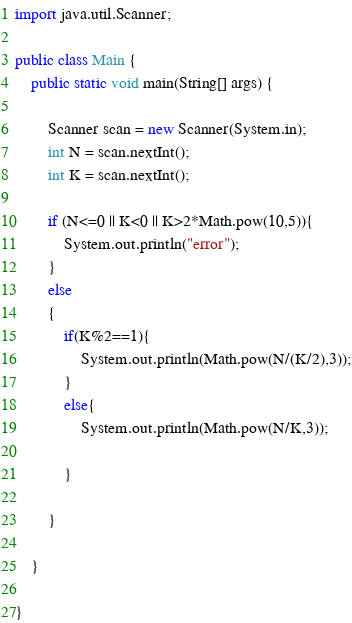Convert code to text. <code><loc_0><loc_0><loc_500><loc_500><_Java_>import java.util.Scanner;

public class Main {
	public static void main(String[] args) {
	
		Scanner scan = new Scanner(System.in);
		int N = scan.nextInt();
		int K = scan.nextInt();
		
		if (N<=0 || K<0 || K>2*Math.pow(10,5)){
			System.out.println("error");
		}
		else
		{
			if(K%2==1){
				System.out.println(Math.pow(N/(K/2),3));
			}
			else{
				System.out.println(Math.pow(N/K,3));
				
			}
			
		}
		
	}

}</code> 